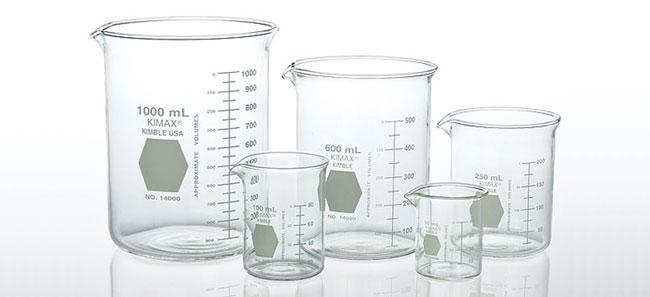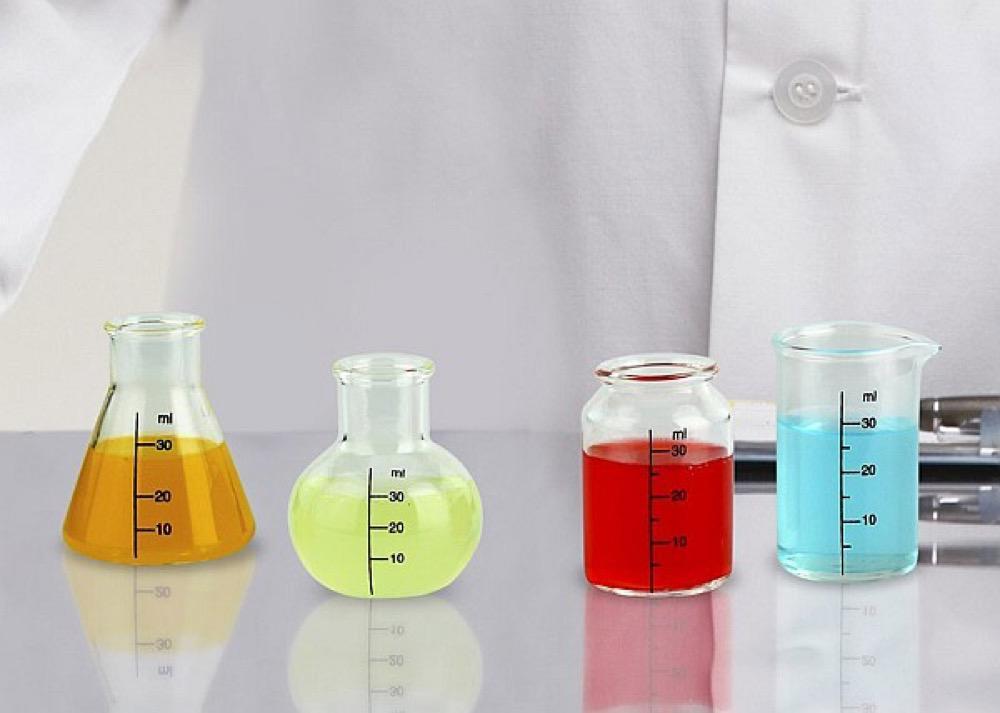The first image is the image on the left, the second image is the image on the right. Examine the images to the left and right. Is the description "The right image includes a beaker containing bright red liquid." accurate? Answer yes or no. Yes. 